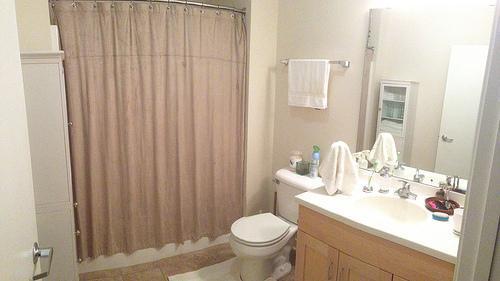How many toilets are in the picture?
Give a very brief answer. 1. 